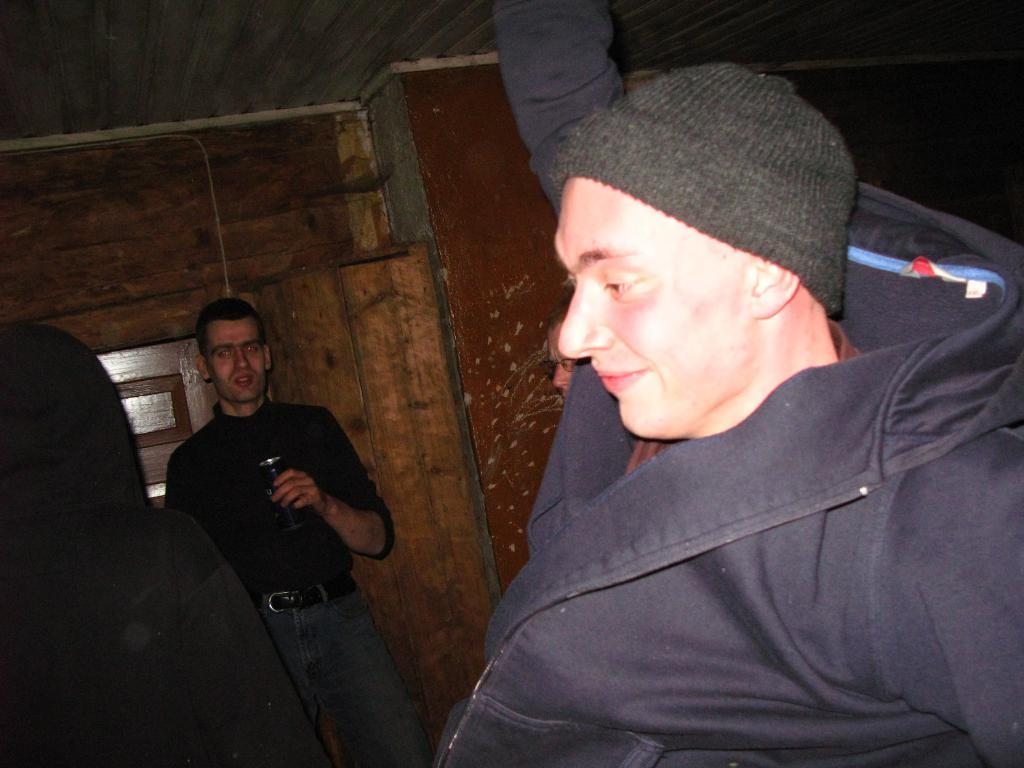How many people are present in the image? There are four persons in the image. Where are the persons located? The persons are standing inside a house. What can be seen in the background of the image? There is a wall visible in the background of the image. What provides shelter in the image? There is a roof for shelter at the top of the image. What type of texture can be seen on the pipe in the image? There is no pipe present in the image. How many trucks are visible in the image? There are no trucks visible in the image. 